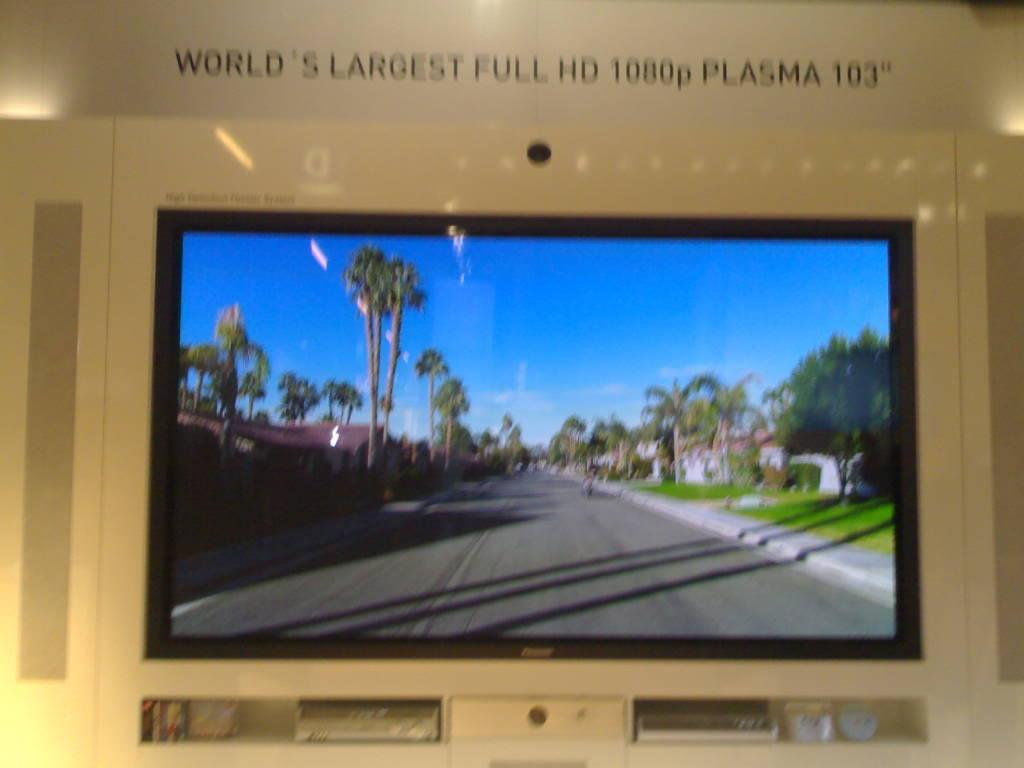<image>
Present a compact description of the photo's key features. the name full hd is labelled above the tv 